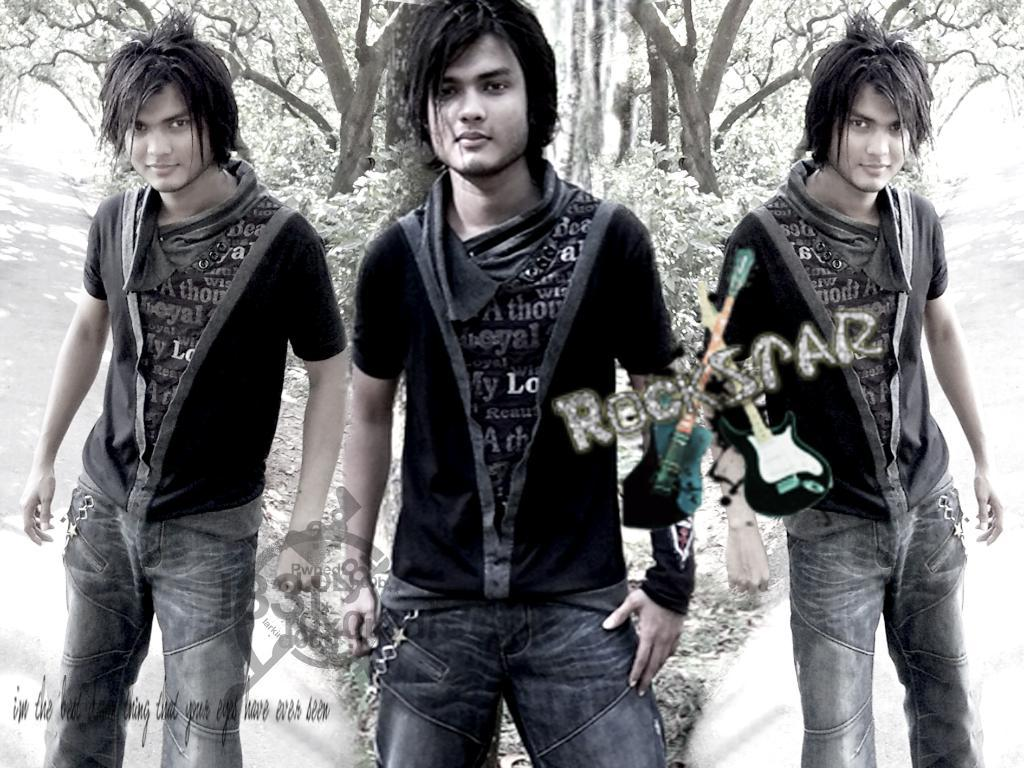What type of visual composition is present in the image? The image contains a collage of photos. Can you describe any people or objects in the collage? There is a person standing in the collage. What is the person wearing in the collage? The person is wearing clothes in the collage. What type of natural scenery can be seen in the collage? There are trees visible in the collage. Is there any text or marking in the image? Yes, there is a watermark in the image. What type of learning can be observed in the collage? There is no learning activity depicted in the collage; it is a collection of photos. Can you see any coastline in the collage? There is no coastline visible in the collage; it features a person, trees, and a watermark. 